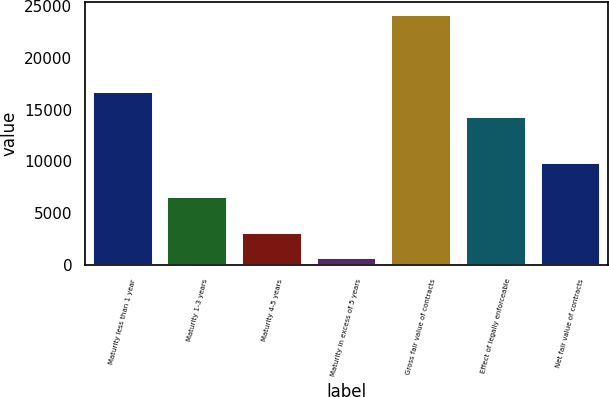<chart> <loc_0><loc_0><loc_500><loc_500><bar_chart><fcel>Maturity less than 1 year<fcel>Maturity 1-3 years<fcel>Maturity 4-5 years<fcel>Maturity in excess of 5 years<fcel>Gross fair value of contracts<fcel>Effect of legally enforceable<fcel>Net fair value of contracts<nl><fcel>16669.6<fcel>6561<fcel>3069.6<fcel>727<fcel>24153<fcel>14327<fcel>9826<nl></chart> 